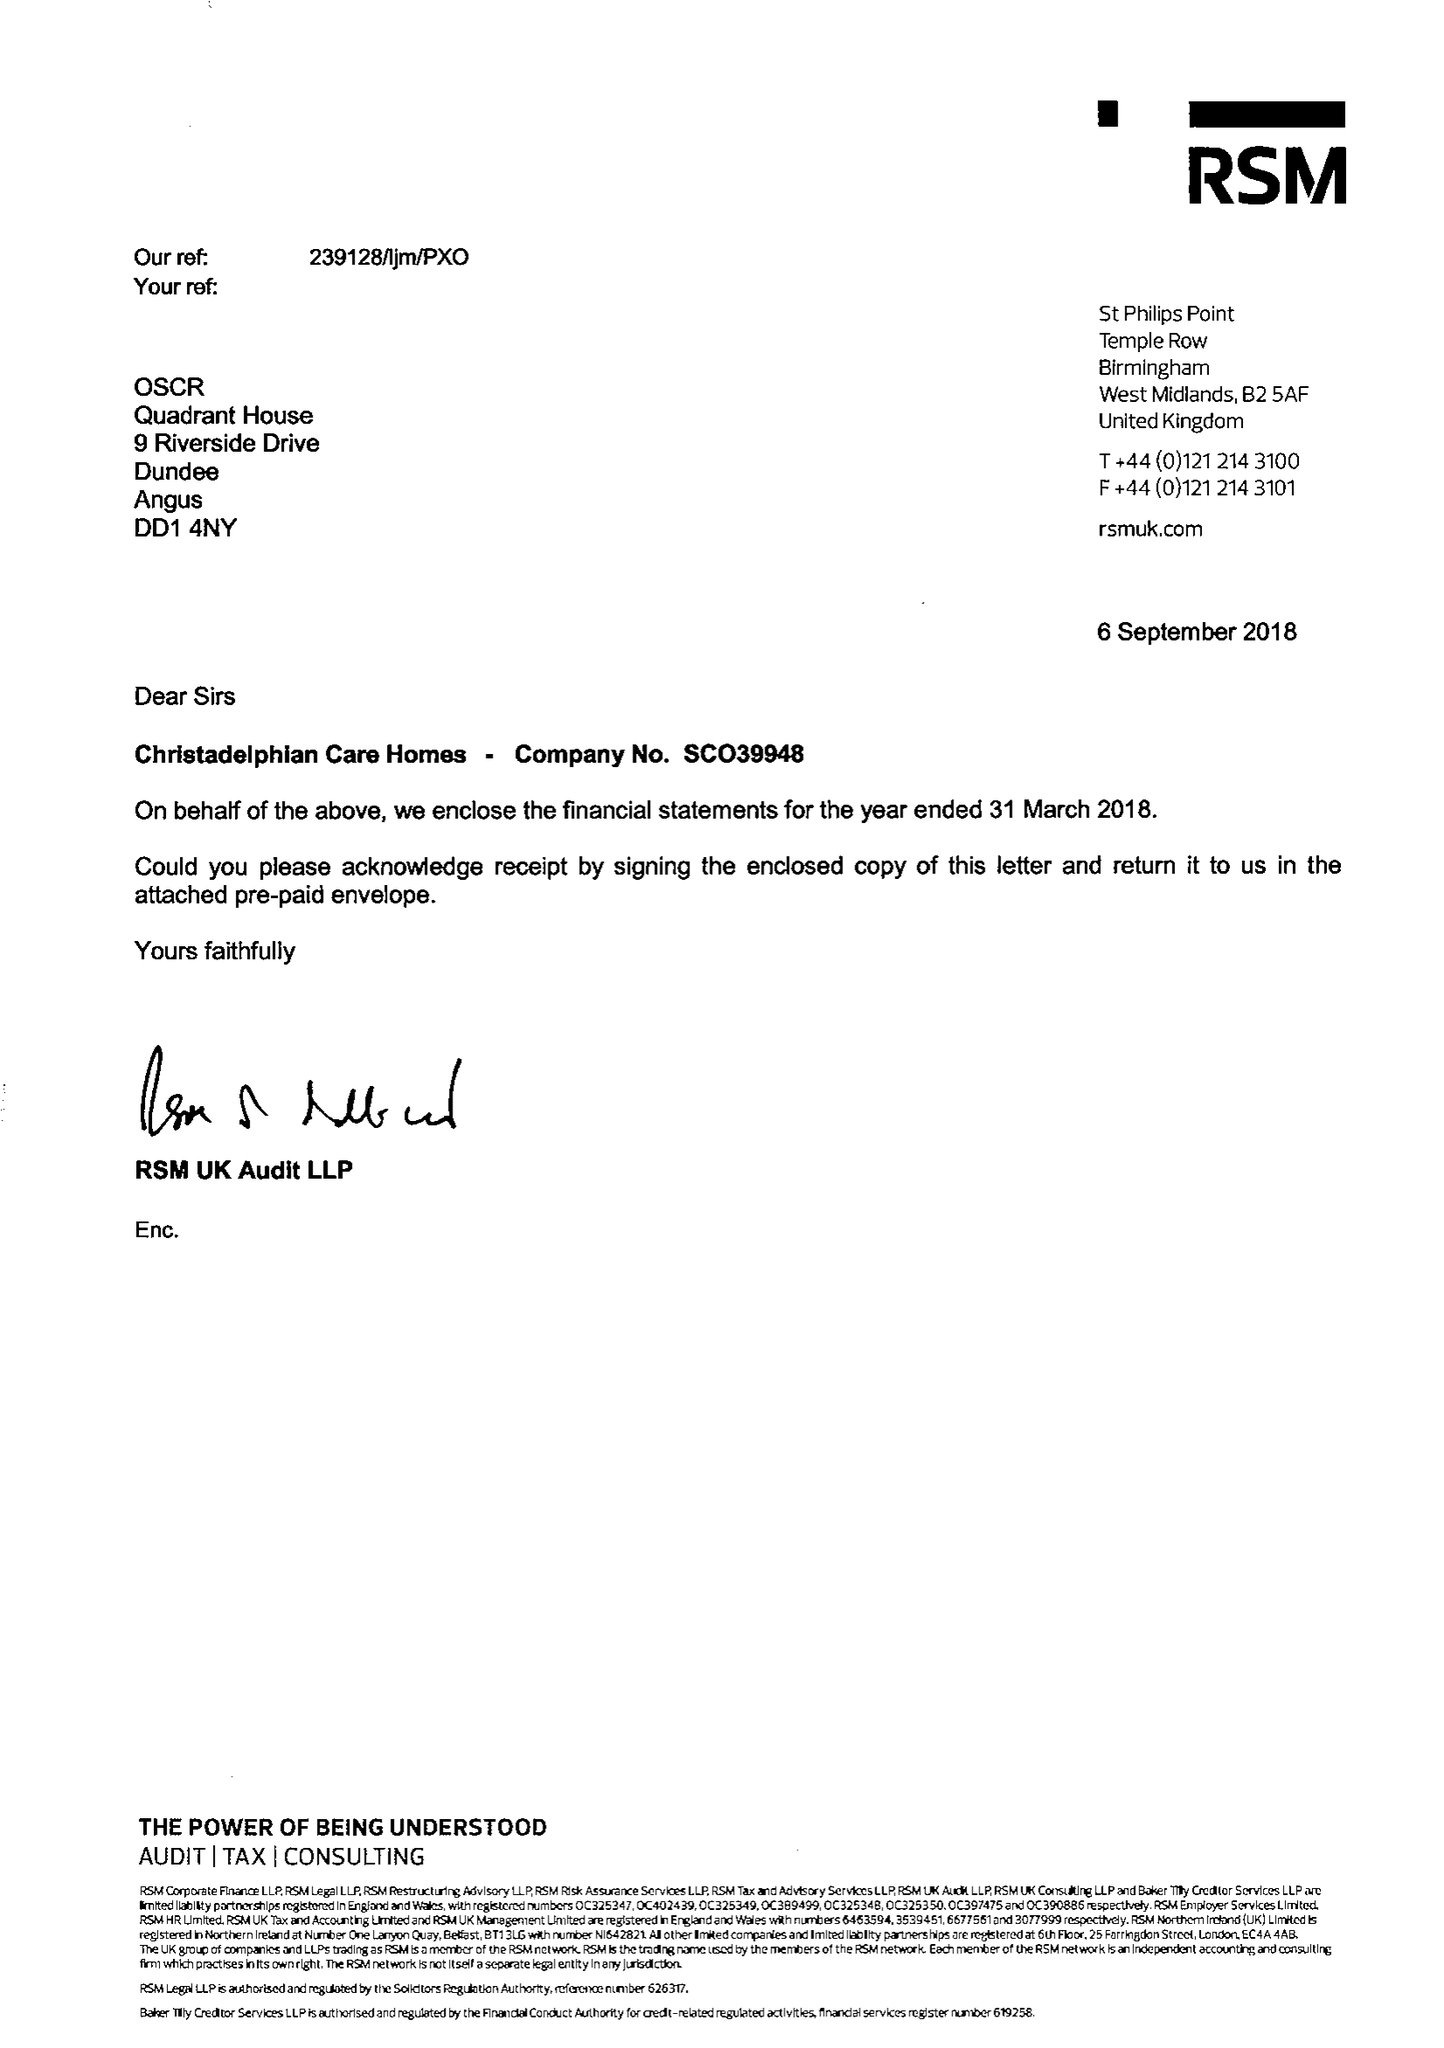What is the value for the spending_annually_in_british_pounds?
Answer the question using a single word or phrase. 10658289.00 